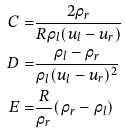<formula> <loc_0><loc_0><loc_500><loc_500>C = & \frac { 2 \rho _ { r } } { R \rho _ { l } ( u _ { l } - u _ { r } ) } \\ D = & \frac { \rho _ { l } - \rho _ { r } } { \rho _ { l } ( u _ { l } - u _ { r } ) ^ { 2 } } \\ E = & \frac { R } { \rho _ { r } } ( \rho _ { r } - \rho _ { l } )</formula> 